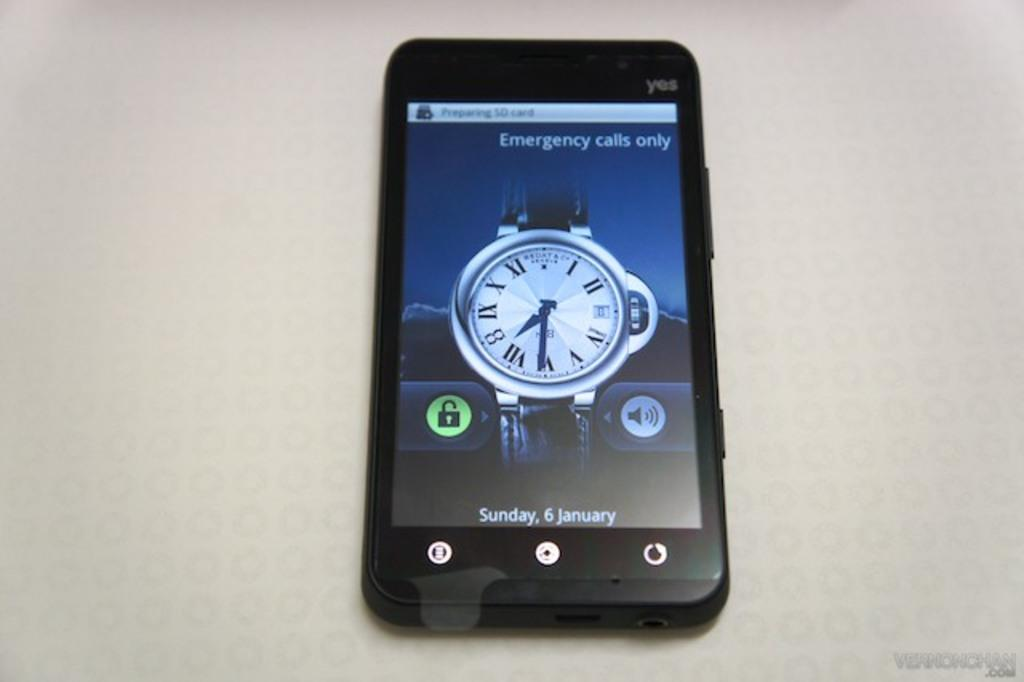<image>
Relay a brief, clear account of the picture shown. Phone screen that has the date on January 6th. 